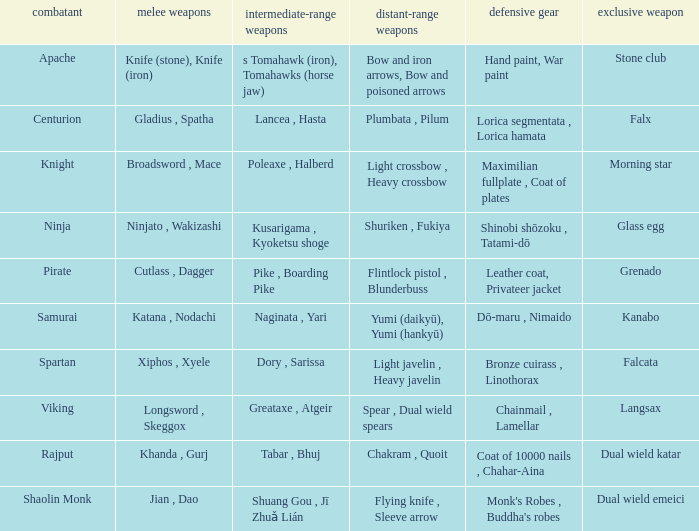If the Close ranged weapons are the knife (stone), knife (iron), what are the Long ranged weapons? Bow and iron arrows, Bow and poisoned arrows. 